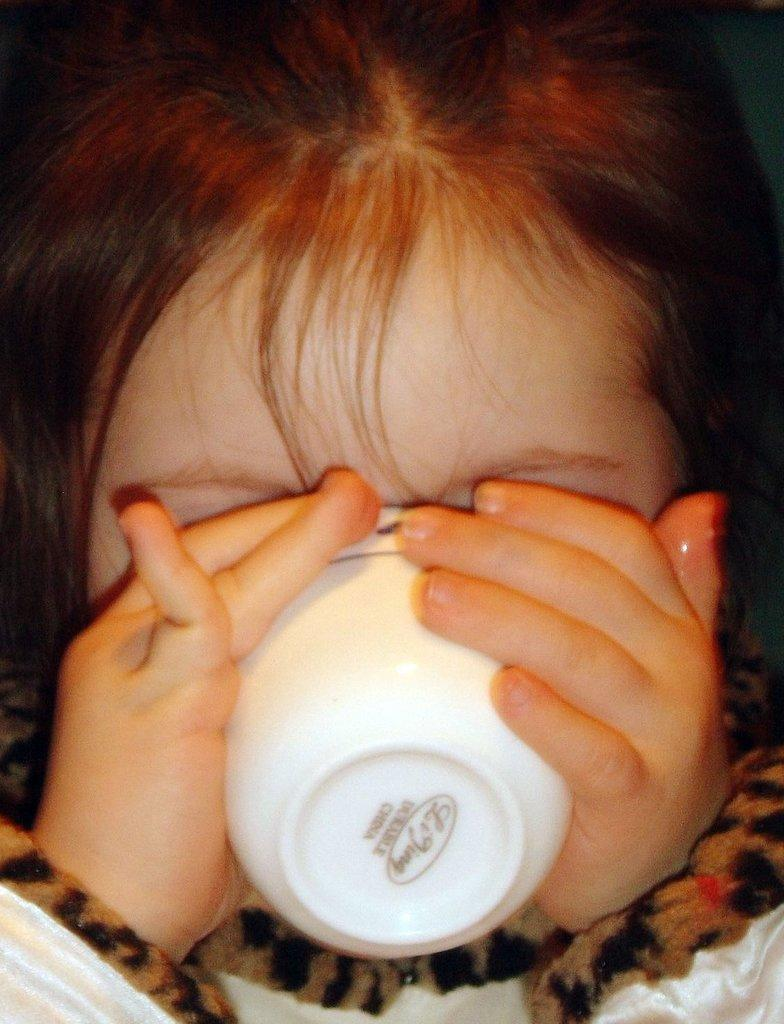What is the main subject of the image? The main subject of the image is a child. What is the child holding in her hands? The child is holding a cup in her hands. Reasoning: Let' Let's think step by step in order to produce the conversation. We start by identifying the main subject of the image, which is the child. Then, we describe what the child is holding, which is a cup. Each question is designed to elicit a specific detail about the image that is known from the provided facts. Absurd Question/Answer: What grade is the child in, based on the image? There is no information about the child's grade in the image. What rhythm is the child dancing to in the image? There is no indication of the child dancing or any rhythm in the image. 